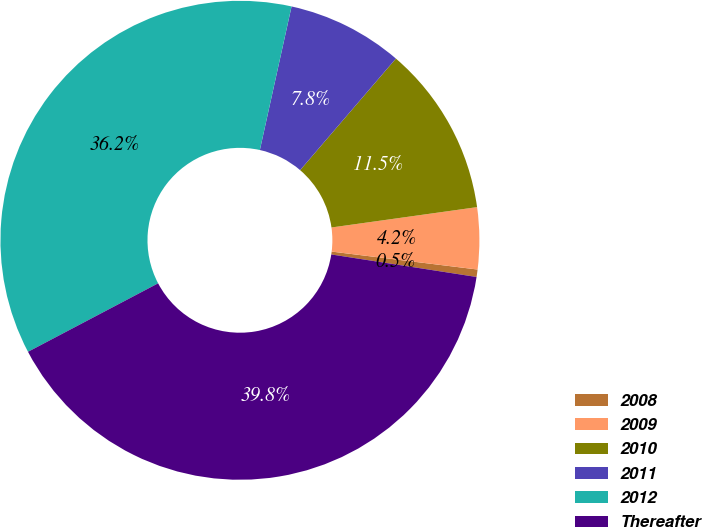<chart> <loc_0><loc_0><loc_500><loc_500><pie_chart><fcel>2008<fcel>2009<fcel>2010<fcel>2011<fcel>2012<fcel>Thereafter<nl><fcel>0.5%<fcel>4.16%<fcel>11.5%<fcel>7.83%<fcel>36.17%<fcel>39.84%<nl></chart> 